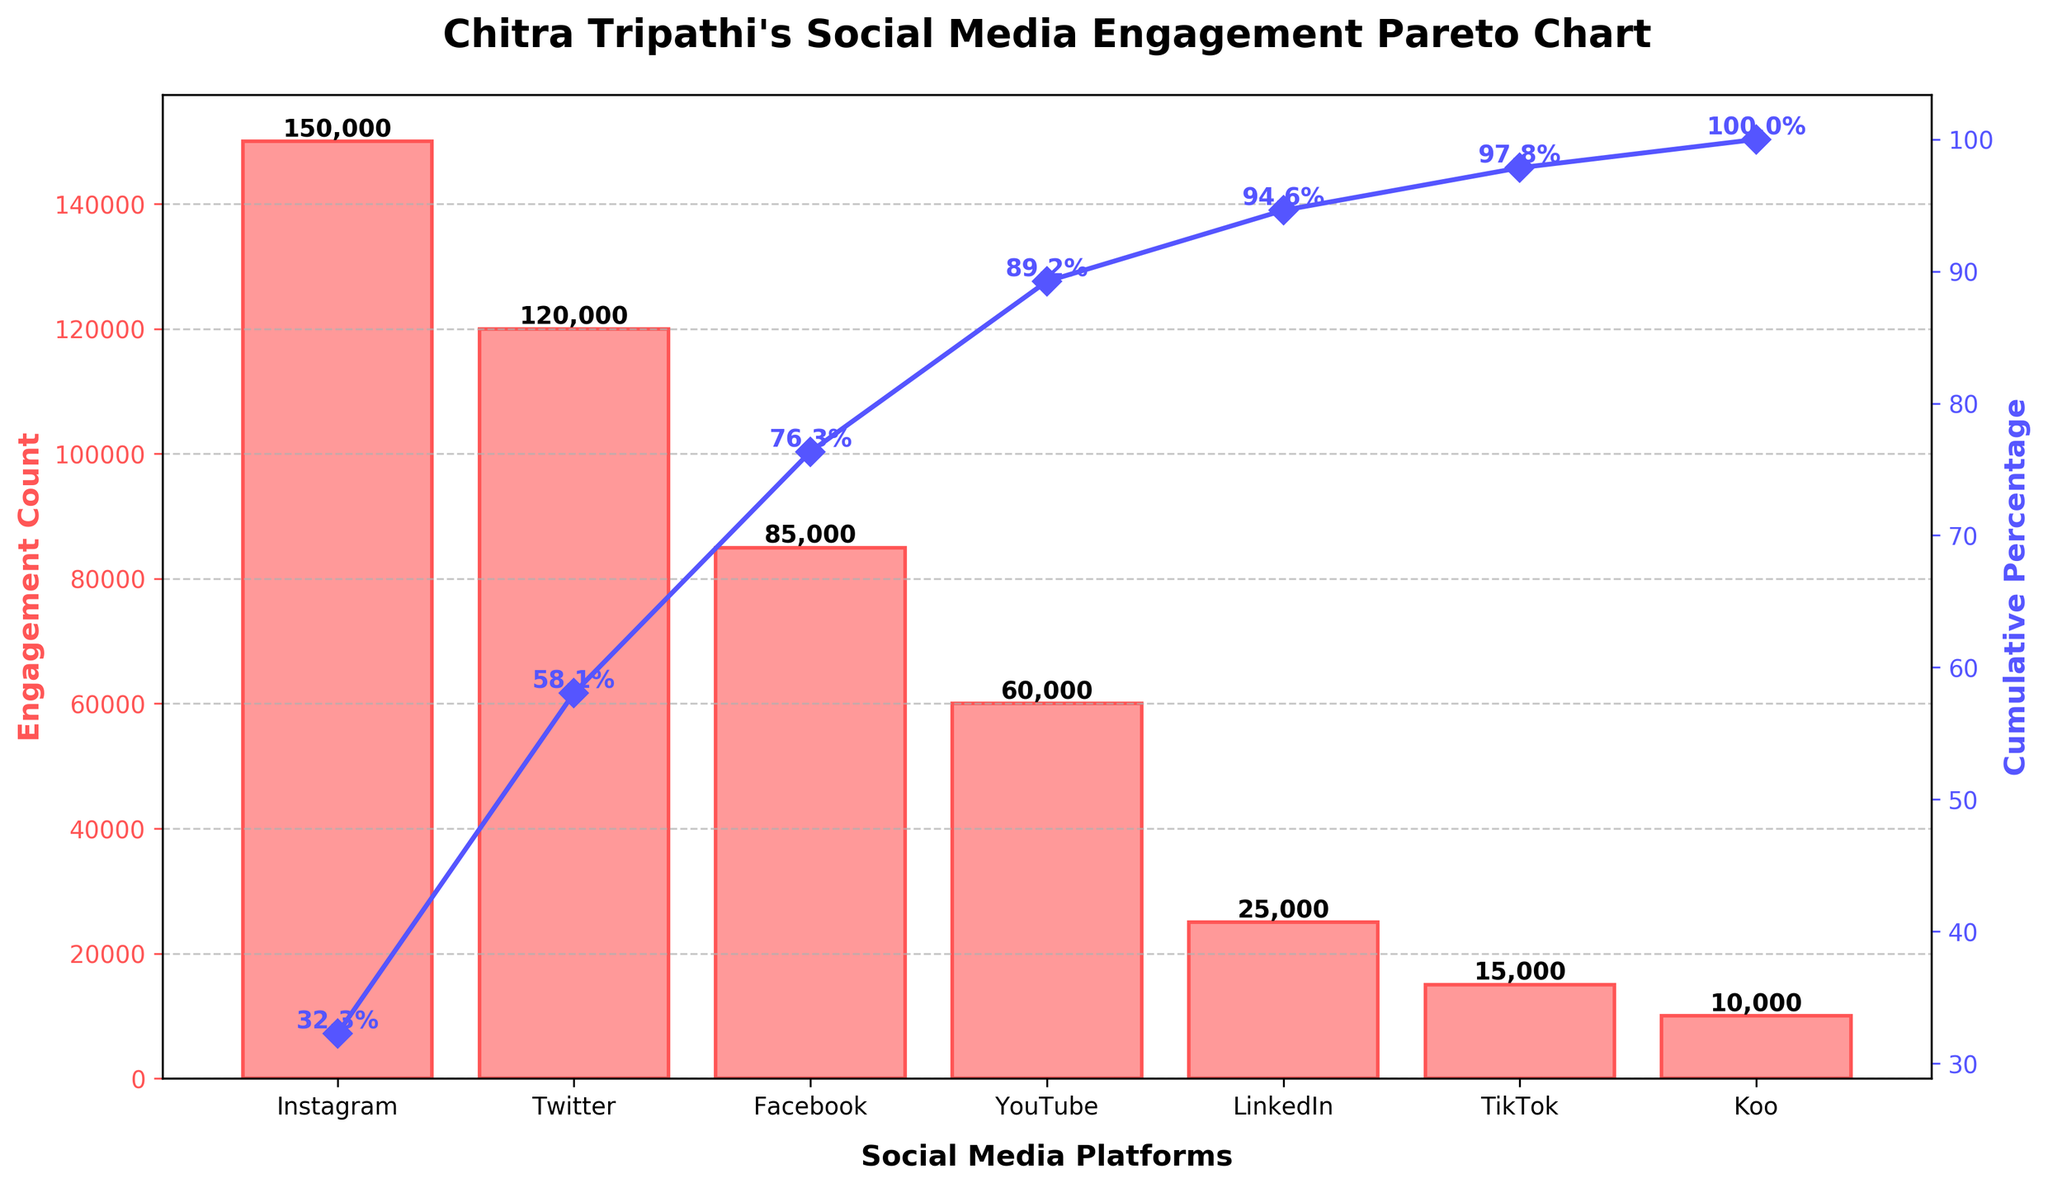Which social media platform has the highest engagement count? The platform with the tallest bar indicates the highest engagement count. According to the bar chart, the tallest bar corresponds to Instagram.
Answer: Instagram What is the cumulative percentage of engagement for the top two platforms? To find the cumulative percentage, we sum the engagement counts of the top two platforms (Instagram and Twitter) and then divide by the total engagement count, converting the result into a percentage. The cumulative percentage line shows approximately 54% for Instagram and around 92% for the sum of Instagram and Twitter.
Answer: Around 92% How does engagement on LinkedIn compare to YouTube? The bar for LinkedIn is shorter than the bar for YouTube. LinkedIn has 25,000 engagements, while YouTube has 60,000 engagements, as indicated by the values on top of the bars.
Answer: LinkedIn has fewer engagements compared to YouTube What total percentage of engagement is accounted for by Instagram, Twitter, and Facebook combined? Adding the engagement counts of Instagram, Twitter, and Facebook gives us 150,000 + 120,000 + 85,000 = 355,000. Dividing by the total engagement count of all platforms (465,000) and converting to a percentage gives us (355,000 / 465,000) * 100 ≈ 76.3%. The cumulative percentage line also confirms this approximate value.
Answer: Around 76.3% What is the title of the figure? The title of the figure is located at the top of the chart. It reads "Chitra Tripathi's Social Media Engagement Pareto Chart".
Answer: Chitra Tripathi's Social Media Engagement Pareto Chart Which platform marks the 80% cumulative percentage on the Pareto chart, and what does this imply? The cumulative percentage line intersects at TikTok, which just crosses the 80% mark. This means that Instagram, Twitter, Facebook, YouTube, LinkedIn, and TikTok together account for about 80% of the total engagement.
Answer: TikTok What is the difference in engagement count between the platform with the highest and lowest engagement? Subtract the engagement count of the platform with the lowest engagement (Koo, 10,000) from the platform with the highest engagement (Instagram, 150,000). The difference is 150,000 - 10,000 = 140,000.
Answer: 140,000 How many platforms have engagement counts below 50,000? By visually inspecting the bars, we observe that LinkedIn, TikTok, and Koo have engagement counts below 50,000. This is a total of three platforms.
Answer: 3 Compare the cumulative percentage increase from Facebook to YouTube. According to the cumulative percentage line, Facebook ends around 92%, and YouTube increases it beyond Koo. The specific increase can be calculated by finding the percentage difference at these points: Facebook at 92% and YouTube above 92% (approx. 92% - 100%). The increase is small and indicates only a few percentage points.
Answer: Small, only a few percentage points 